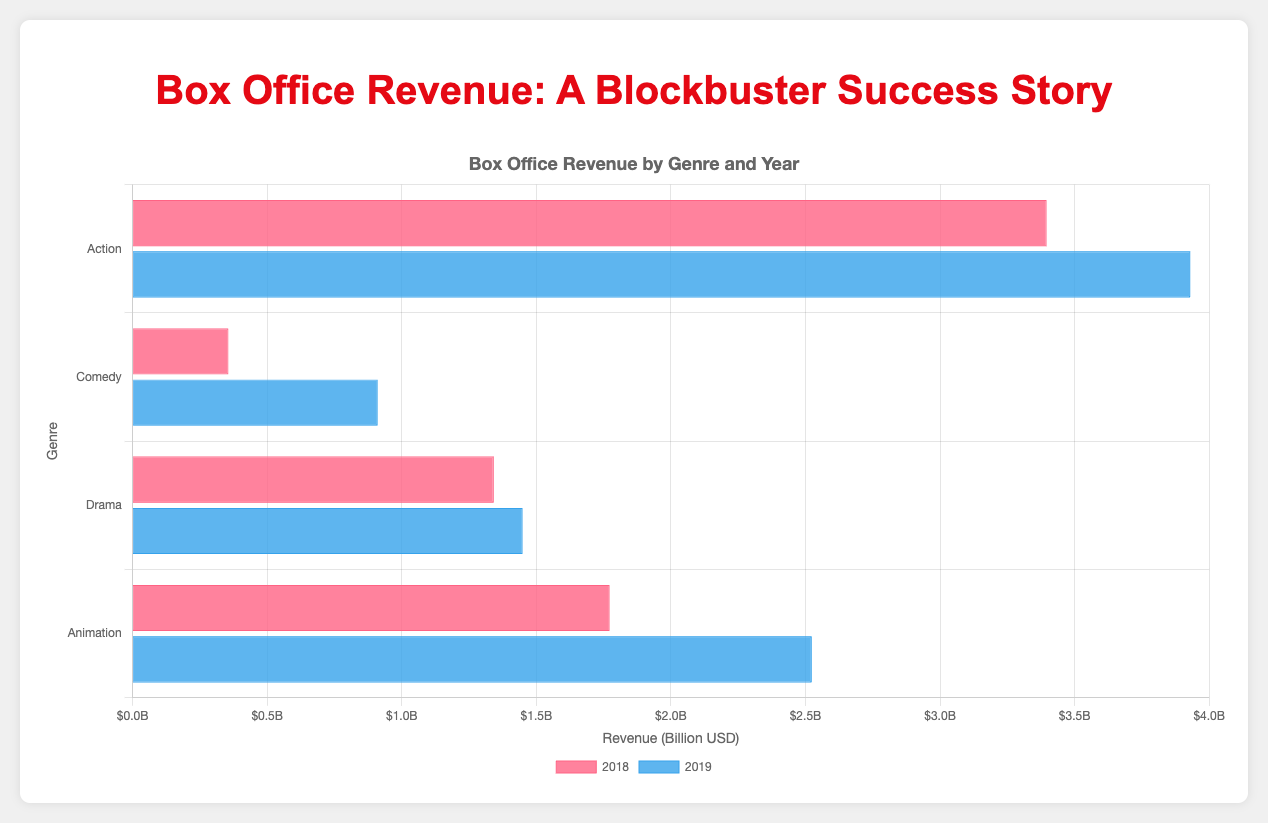Which genre had the highest total box office revenue in 2019? To determine this, compare the lengths of the blue bars for 2019 across all genres. The genre with the longest bar represents the highest revenue. Action has the longest blue bar.
Answer: Action How much more revenue did Animation films make in 2019 compared to 2018? Check the lengths of the red and blue bars for Animation to find their revenues in 2018 and 2019, respectively. Subtract the 2018 revenue from the 2019 revenue: \(1.45 - 1.243 = 0.207\) billion USD.
Answer: 0.207 billion USD Which year had higher total revenue for Comedy films? Compare the red bar (2018) and the blue bar (2019) for Comedy. The blue bar is longer, indicating that 2019 had higher total revenue for Comedy films.
Answer: 2019 What is the average revenue of Drama films in 2018 and 2019 combined? Calculate the total revenue for Drama in 2018 and 2019 by adding their respective bars: \(0.905 + 0.436 + 1.074 + 0.374 = 2.789\) billion USD. Divide by the number of years (2) to get the average.
Answer: 1.3945 billion USD Which genre saw the largest increase in total revenue from 2018 to 2019? Calculate the difference in lengths of the bars for each genre between 2018 and 2019. Animation shows the largest increase from approximately \(1.243\) to \(1.45\) billion USD.
Answer: Animation What is the total box office revenue for Animation films in both years combined? Sum up the lengths of the bars for Animation in both years: \(1.243 + 1.45 = 2.693\) billion USD.
Answer: 2.693 billion USD How much revenue did Action films generate on average per year? Sum the revenues of Action films in 2018 and 2019: \(2.048 + 1.346 + 2.798 + 1.131 = 7.323\) billion USD. Divide by 2 years to find the average.
Answer: 3.6615 billion USD Which genre had the smallest total box office revenue in 2018? Compare the lengths of the red bars for all genres in 2018. The shortest red bar belongs to Comedy.
Answer: Comedy Did any genre experience a decline in revenue from 2018 to 2019? Compare the lengths of the red and blue bars for each genre. All genres except Comedy have blue bars longer than or equal to their red bars. Comedy's revenue declined.
Answer: Comedy By how much did Drama films' revenue change from 2018 to 2019? Subtract the length of the red bar (2018) from the blue bar (2019) for Drama: \(1.074 - 0.905 = 0.169\) billion USD.
Answer: 0.169 billion USD 